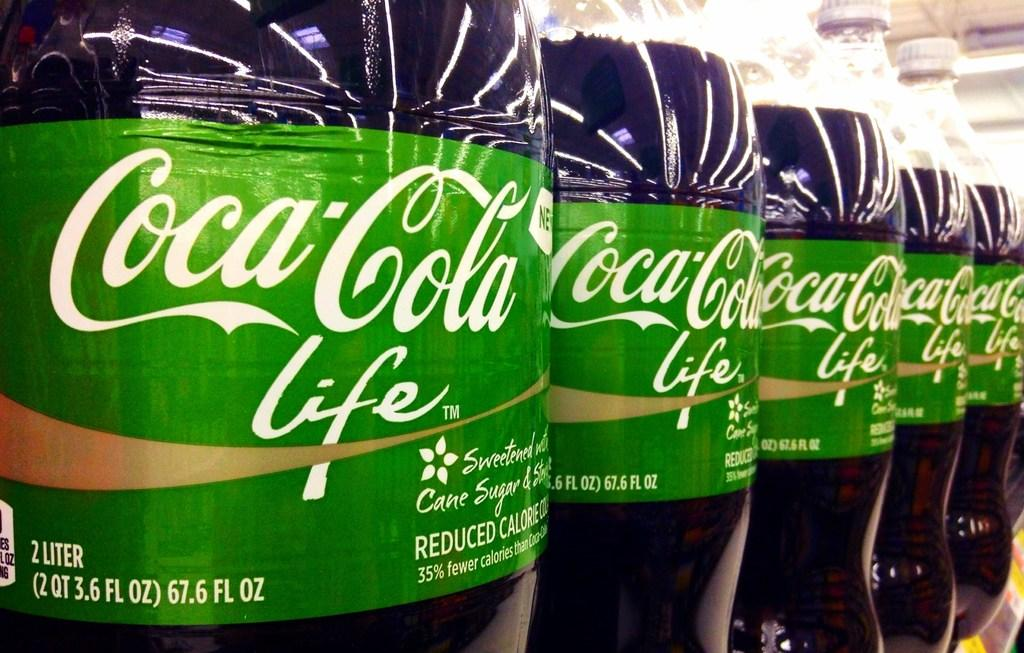What type of bottles can be seen in the image? There are coca cola bottles in the image. How are the bottles arranged in the image? The bottles are arranged in a row. What is the status of the bottle lids in the image? The lids of the bottles are closed. Can you hear the fairies singing in the image? There are no fairies or sounds present in the image, so it is not possible to hear any singing. 